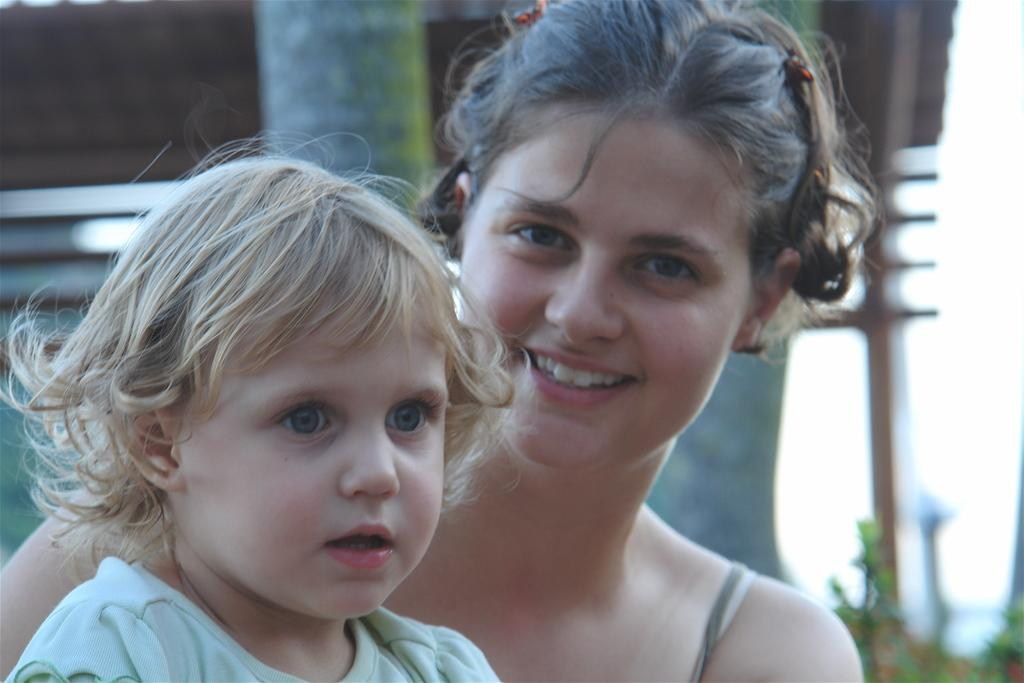How many people are in the image? There are two persons in the image. What are the persons doing in the image? The persons are sitting. What expression do the persons have in the image? The persons are smiling. What can be seen behind the persons in the image? There is a tree and a shed behind the persons. What type of sofa is visible in the image? There is no sofa present in the image. What is the temperature inside the shed in the image? The image does not provide information about the temperature inside the shed. 